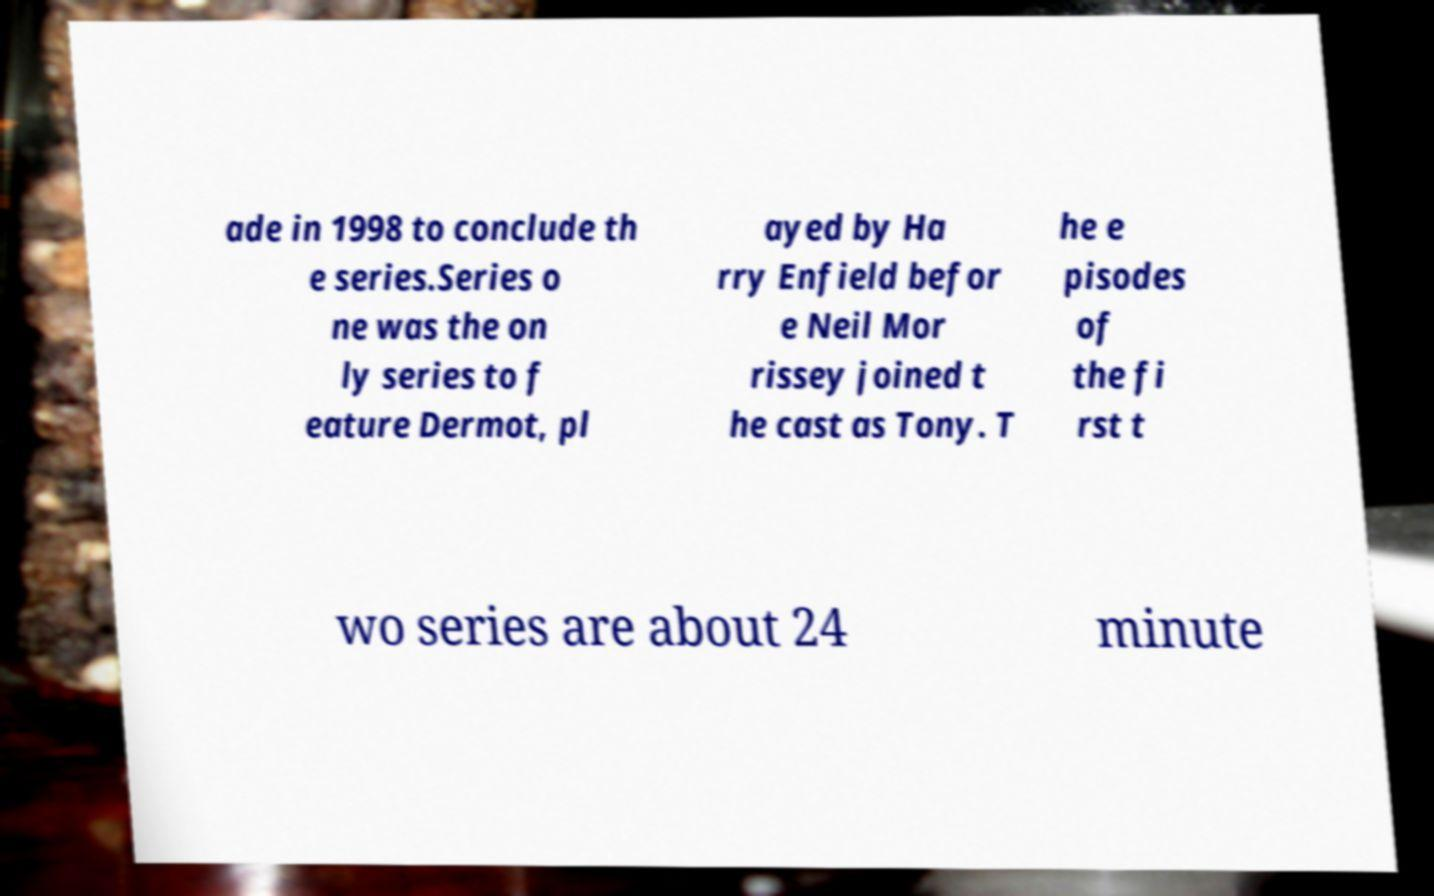Could you assist in decoding the text presented in this image and type it out clearly? ade in 1998 to conclude th e series.Series o ne was the on ly series to f eature Dermot, pl ayed by Ha rry Enfield befor e Neil Mor rissey joined t he cast as Tony. T he e pisodes of the fi rst t wo series are about 24 minute 